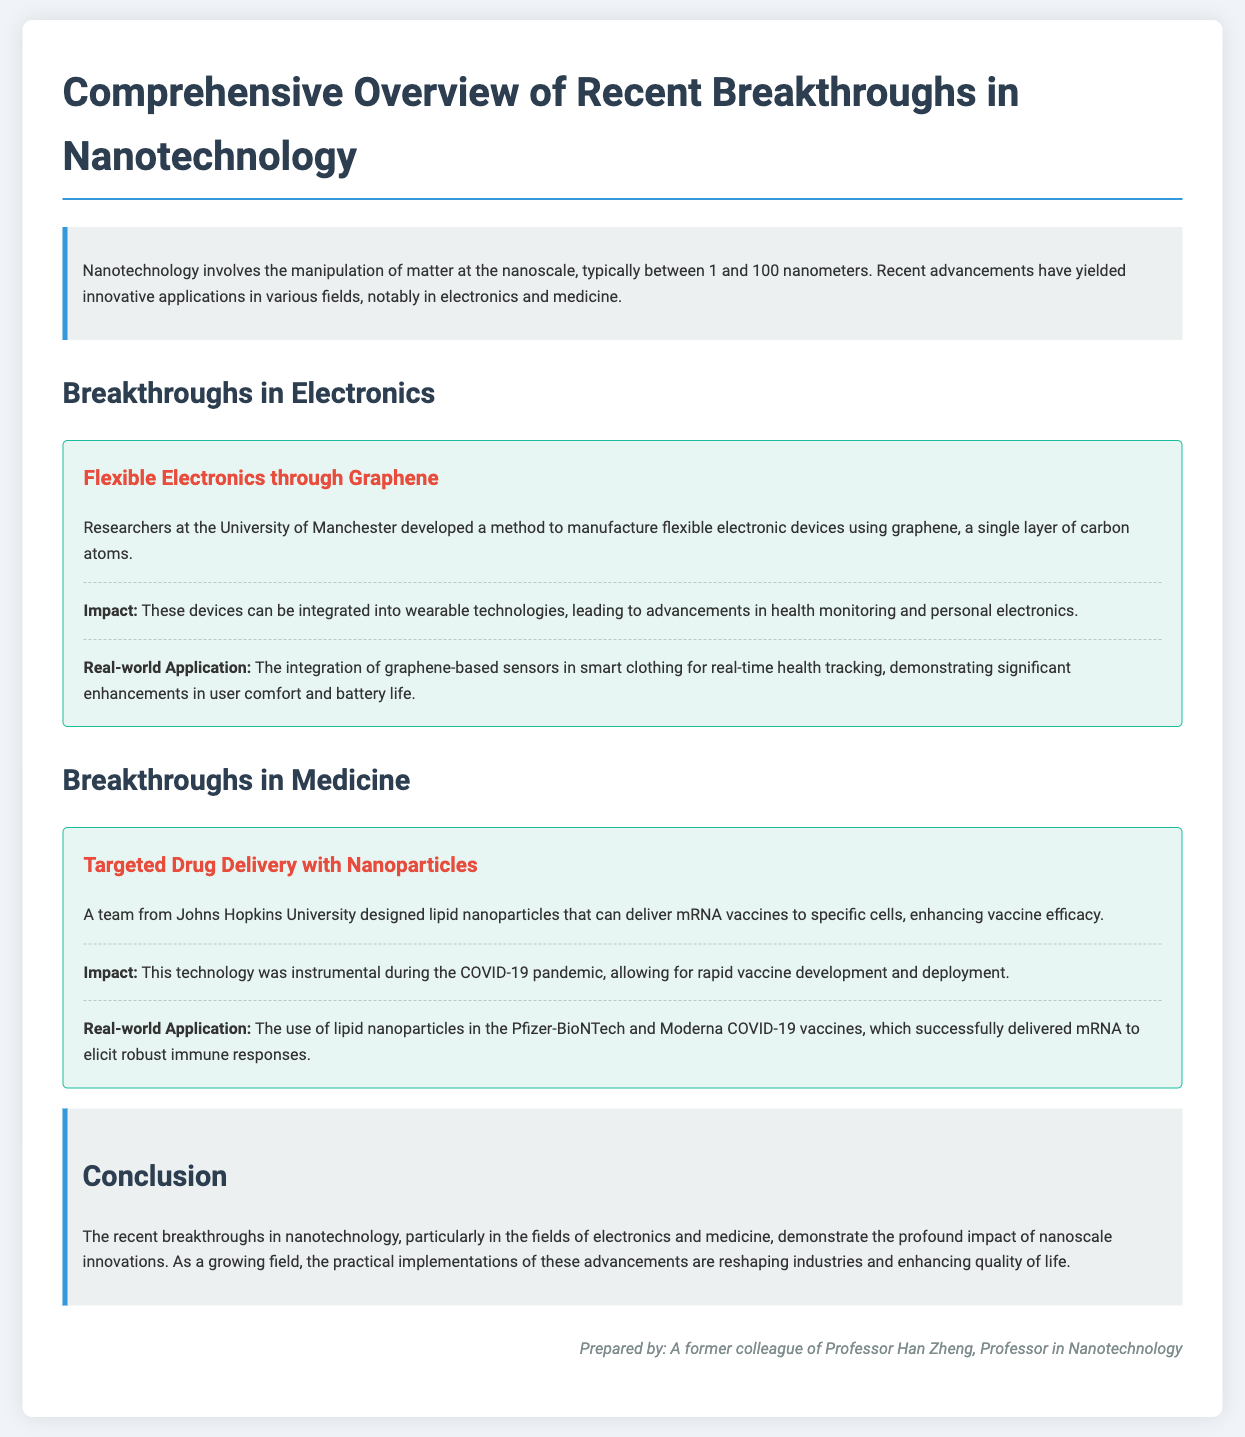What is the main focus of the document? The document provides a comprehensive overview of recent breakthroughs in nanotechnology, particularly in electronics and medicine.
Answer: Breakthroughs in nanotechnology Who developed flexible electronic devices using graphene? The researchers at the University of Manchester developed flexible electronic devices using graphene.
Answer: University of Manchester What is a notable real-world application of lipid nanoparticles? The use of lipid nanoparticles in the Pfizer-BioNTech and Moderna COVID-19 vaccines is a notable real-world application.
Answer: Pfizer-BioNTech and Moderna COVID-19 vaccines What type of materials are used for the flexible electronics discussed? The flexible electronics are made from graphene, which is a single layer of carbon atoms.
Answer: Graphene What was instrumental during the COVID-19 pandemic according to the document? The targeted drug delivery with nanoparticles technology was instrumental during the COVID-19 pandemic.
Answer: Targeted drug delivery with nanoparticles Which two fields are highlighted for breakthroughs in the document? The document highlights breakthroughs in electronics and medicine.
Answer: Electronics and medicine What enhances vaccine efficacy according to the case study? Lipid nanoparticles designed to deliver mRNA vaccines to specific cells enhance vaccine efficacy.
Answer: Lipid nanoparticles What technology was designed by a team from Johns Hopkins University? The team from Johns Hopkins University designed lipid nanoparticles for targeted drug delivery.
Answer: Lipid nanoparticles 